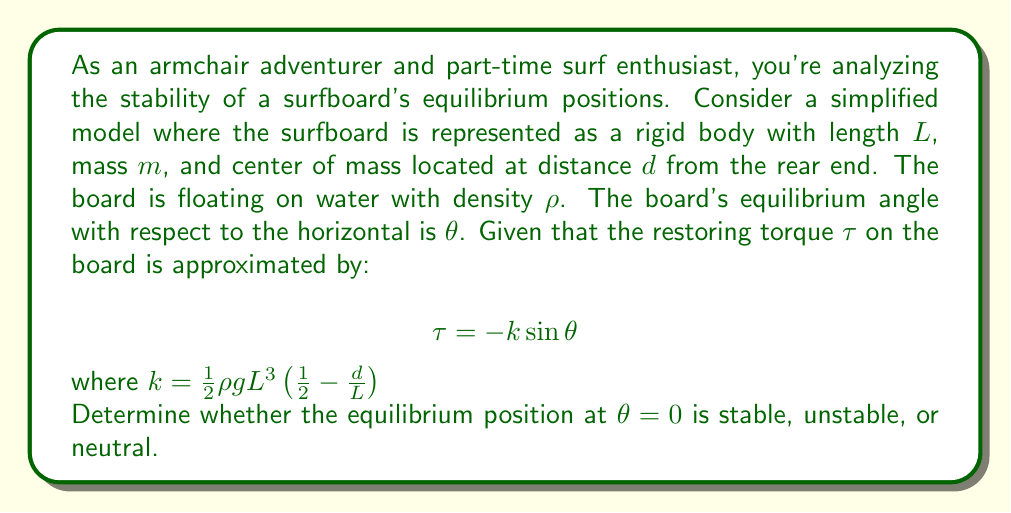Teach me how to tackle this problem. To analyze the stability of the equilibrium position, we need to examine the behavior of the system near $\theta = 0$. We'll follow these steps:

1) First, recall that for a system described by $\frac{d^2\theta}{dt^2} = f(\theta)$, the equilibrium is:
   - Stable if $\frac{df}{d\theta} < 0$ at the equilibrium point
   - Unstable if $\frac{df}{d\theta} > 0$ at the equilibrium point
   - Neutral if $\frac{df}{d\theta} = 0$ at the equilibrium point

2) In our case, the equation of motion for the surfboard is:

   $$I\frac{d^2\theta}{dt^2} = \tau = -k\sin\theta$$

   where $I$ is the moment of inertia of the board.

3) Dividing both sides by $I$, we get:

   $$\frac{d^2\theta}{dt^2} = -\frac{k}{I}\sin\theta$$

4) Let $f(\theta) = -\frac{k}{I}\sin\theta$. We need to evaluate $\frac{df}{d\theta}$ at $\theta = 0$:

   $$\frac{df}{d\theta} = -\frac{k}{I}\cos\theta$$

5) At $\theta = 0$:

   $$\left.\frac{df}{d\theta}\right|_{\theta=0} = -\frac{k}{I}$$

6) Now, we need to determine the sign of $k$:

   $$k = \frac{1}{2}\rho g L^3 \left(\frac{1}{2} - \frac{d}{L}\right)$$

7) For a typical surfboard, the center of mass $d$ is usually closer to the middle than the rear end, so $\frac{d}{L} > \frac{1}{4}$. This makes $\left(\frac{1}{2} - \frac{d}{L}\right) < \frac{1}{4}$, and thus $k > 0$.

8) Since $k > 0$ and $I > 0$ (as it's a moment of inertia), we have:

   $$\left.\frac{df}{d\theta}\right|_{\theta=0} = -\frac{k}{I} < 0$$

9) Therefore, the equilibrium at $\theta = 0$ is stable.
Answer: Stable equilibrium 